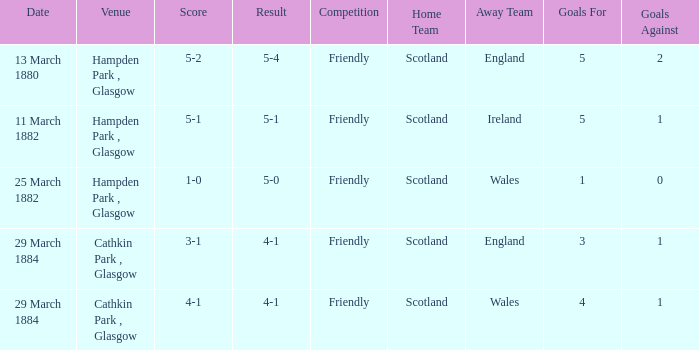Which item has a score of 5-1? 5-1. 